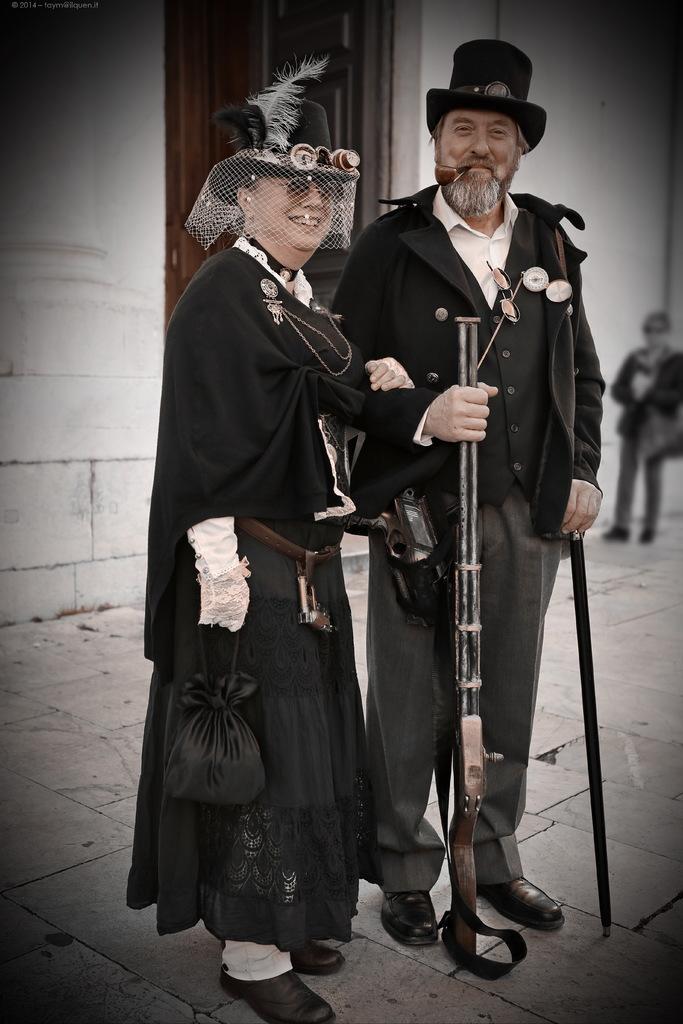Could you give a brief overview of what you see in this image? In this image we can see two persons wearing similar dress caps and holding weapons in their hands standing on the floor one of the person is smoking and at the background of the image there is wall. 